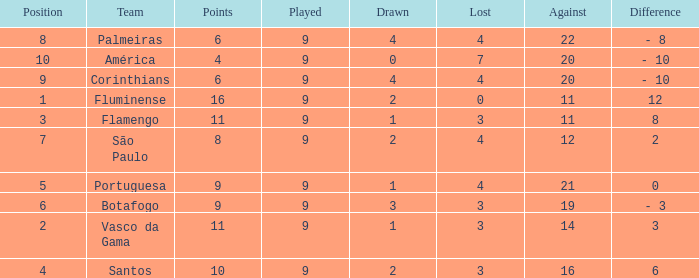Which Position has a Played larger than 9? None. I'm looking to parse the entire table for insights. Could you assist me with that? {'header': ['Position', 'Team', 'Points', 'Played', 'Drawn', 'Lost', 'Against', 'Difference'], 'rows': [['8', 'Palmeiras', '6', '9', '4', '4', '22', '- 8'], ['10', 'América', '4', '9', '0', '7', '20', '- 10'], ['9', 'Corinthians', '6', '9', '4', '4', '20', '- 10'], ['1', 'Fluminense', '16', '9', '2', '0', '11', '12'], ['3', 'Flamengo', '11', '9', '1', '3', '11', '8'], ['7', 'São Paulo', '8', '9', '2', '4', '12', '2'], ['5', 'Portuguesa', '9', '9', '1', '4', '21', '0'], ['6', 'Botafogo', '9', '9', '3', '3', '19', '- 3'], ['2', 'Vasco da Gama', '11', '9', '1', '3', '14', '3'], ['4', 'Santos', '10', '9', '2', '3', '16', '6']]} 